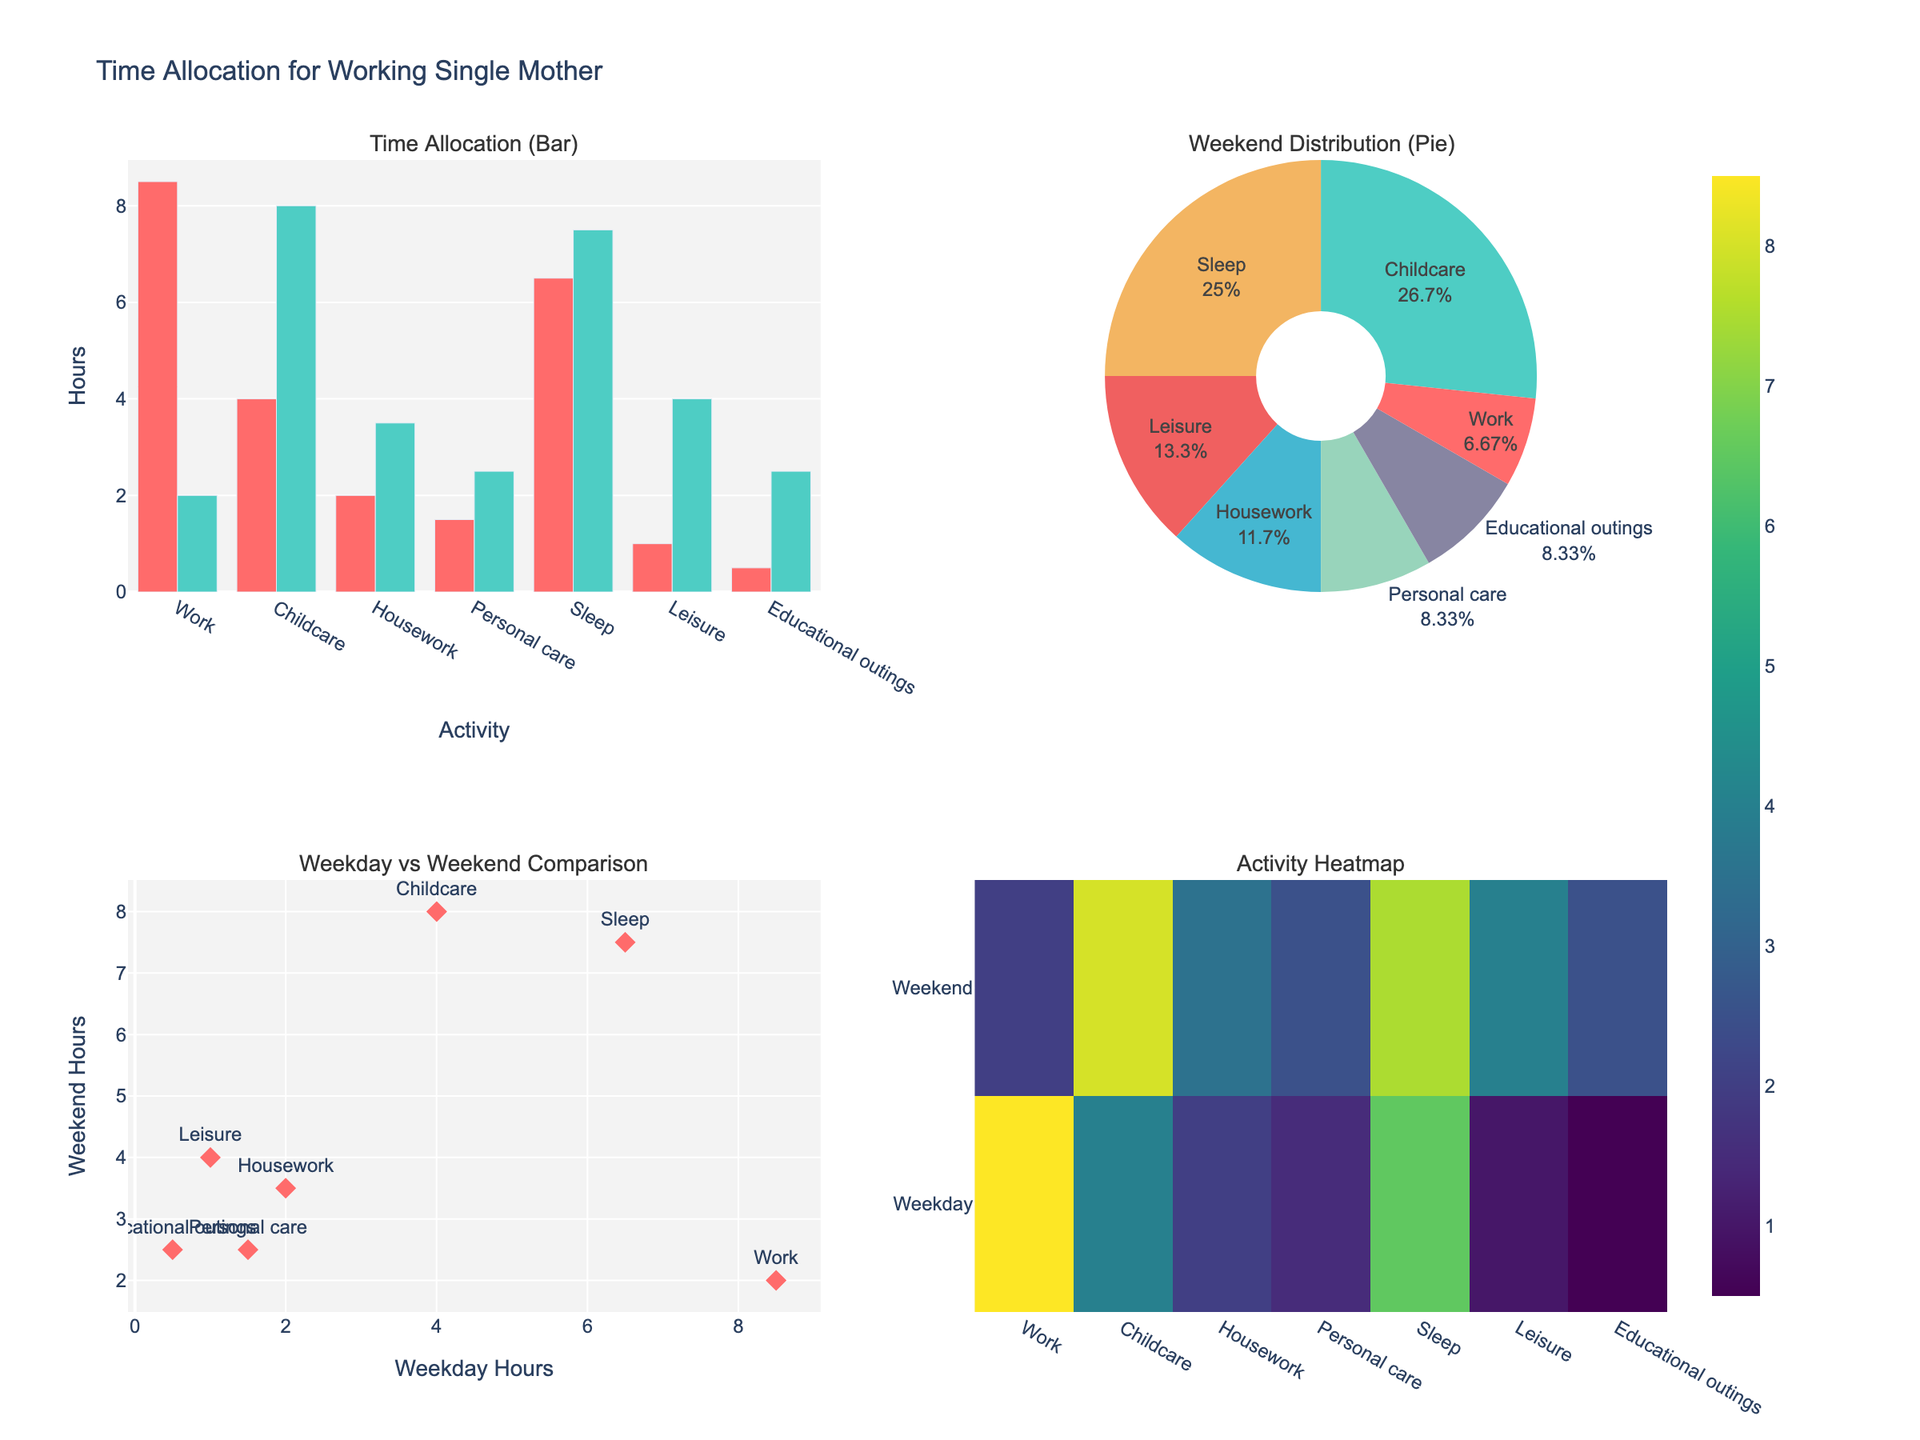What activity has the highest number of hours on weekends according to the pie chart? By looking at the pie chart on the upper right subplot, we observe that "Childcare" has the largest slice, indicating the highest number of hours on weekends.
Answer: Childcare How many more hours are spent on work on weekdays compared to weekends according to the bar chart? The bar chart on the upper left subplot shows that 8.5 hours are spent on work on weekdays and 2.0 hours on weekends. The difference is calculated as 8.5 - 2.0.
Answer: 6.5 hours What is the total number of hours spent on sleep over both weekdays and weekends? We can see from the bar chart in the upper left subplot that 6.5 hours are spent on sleep on weekdays and 7.5 hours on weekends. The total is 6.5 + 7.5.
Answer: 14 hours Which activity shows a similar number of hours allocated on both weekdays and weekends according to the scatter plot? The scatter plot in the lower left subplot plots "Weekday Hours" on the x-axis and "Weekend Hours" on the y-axis. The point for "Housework" is the closest to a vertical line indicating similar hours on both days.
Answer: Housework What percentage of the weekend is spent on leisure activities, as shown in the pie chart? By examining the pie chart in the upper right subplot, we see that the slice corresponding to "Leisure" indicates 4.0 hours out of the total, which converts to approximately 23.5%.
Answer: 23.5% Which activity has the smallest difference in hours between weekdays and weekends according to the bar chart? The bar chart in the upper left subplot shows the least difference in height between the bars for "Housework," indicating the smallest difference in hours between weekdays and weekends.
Answer: Housework How are hours distributed among different activities for weekends according to the heatmap? The heatmap in the lower right subplot shows the hours for various activities on weekends. The color intensity is higher for activities with more hours, such as "Childcare" and "Leisure," compared to lower intensity for "Work" and "Personal care."
Answer: Childcare and Leisure have more hours; Work and Personal care have fewer What is the average number of hours spent on personal care across weekdays and weekends? The bar chart indicates that 1.5 hours are spent on personal care on weekdays and 2.5 hours on weekends. The average is calculated as (1.5 + 2.5) / 2.
Answer: 2 hours How do the weekday and weekend hours for educational outings compare? The upper left bar chart shows "Educational outings" with 0.5 hours on weekdays and 2.5 hours on weekends. Weekends have 2.0 more hours compared to weekdays.
Answer: 2.0 more hours Which activity, according to the heatmap, holds the maximum total hours when combining weekday and weekend hours? On the heatmap, the highest color intensity appears for "Childcare," indicating it has the highest combined hours across weekdays and weekends compared to other activities.
Answer: Childcare 